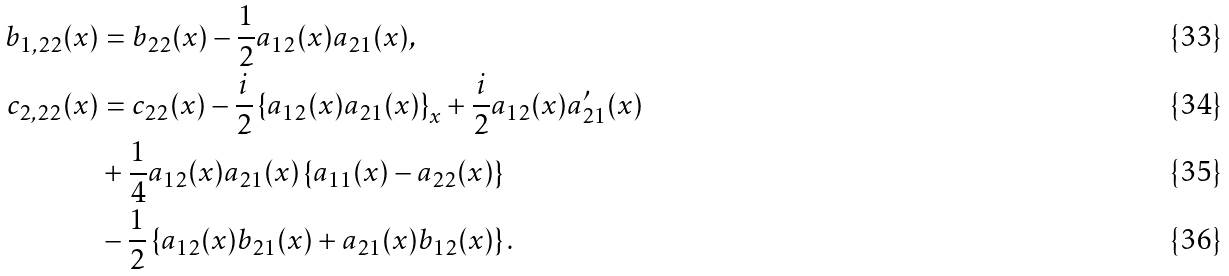Convert formula to latex. <formula><loc_0><loc_0><loc_500><loc_500>b _ { 1 , 2 2 } ( x ) & = b _ { 2 2 } ( x ) - \frac { 1 } { 2 } a _ { 1 2 } ( x ) a _ { 2 1 } ( x ) , \\ c _ { 2 , 2 2 } ( x ) & = c _ { 2 2 } ( x ) - \frac { i } { 2 } \left \{ a _ { 1 2 } ( x ) a _ { 2 1 } ( x ) \right \} _ { x } + \frac { i } { 2 } a _ { 1 2 } ( x ) a _ { 2 1 } ^ { \prime } ( x ) \\ & + \frac { 1 } { 4 } a _ { 1 2 } ( x ) a _ { 2 1 } ( x ) \left \{ a _ { 1 1 } ( x ) - a _ { 2 2 } ( x ) \right \} \\ & - \frac { 1 } { 2 } \left \{ a _ { 1 2 } ( x ) b _ { 2 1 } ( x ) + a _ { 2 1 } ( x ) b _ { 1 2 } ( x ) \right \} .</formula> 